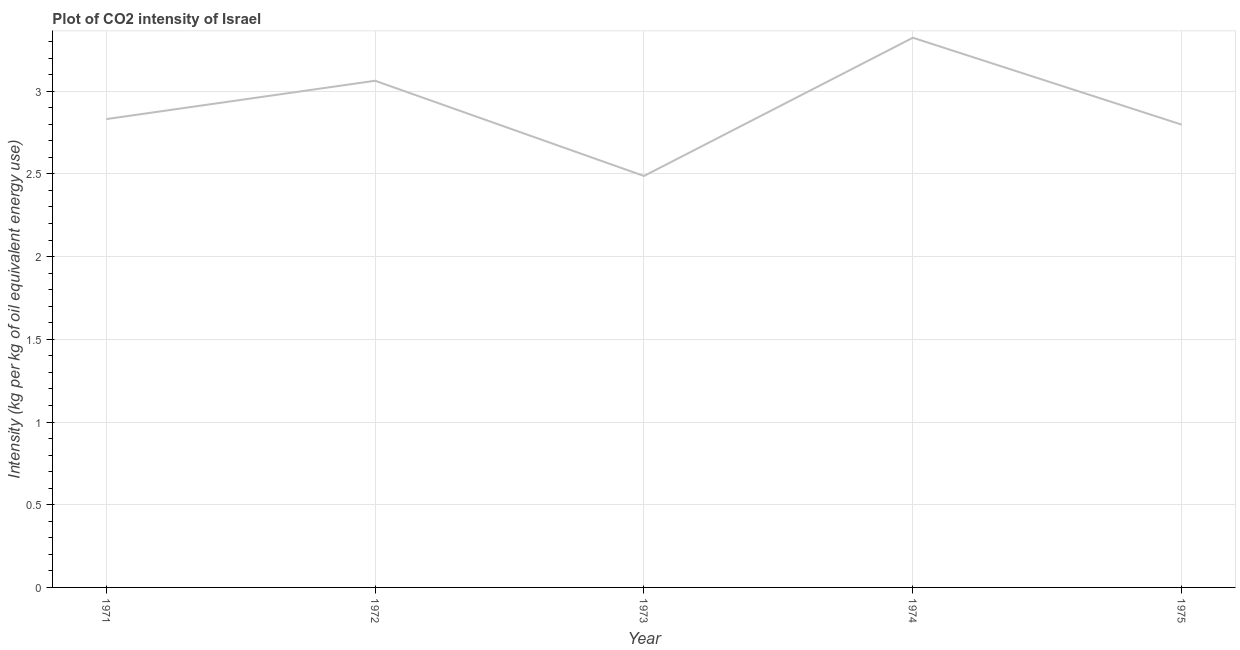What is the co2 intensity in 1974?
Keep it short and to the point. 3.32. Across all years, what is the maximum co2 intensity?
Provide a short and direct response. 3.32. Across all years, what is the minimum co2 intensity?
Offer a very short reply. 2.49. In which year was the co2 intensity maximum?
Your answer should be compact. 1974. In which year was the co2 intensity minimum?
Provide a succinct answer. 1973. What is the sum of the co2 intensity?
Your answer should be very brief. 14.5. What is the difference between the co2 intensity in 1971 and 1974?
Your answer should be very brief. -0.49. What is the average co2 intensity per year?
Provide a succinct answer. 2.9. What is the median co2 intensity?
Your response must be concise. 2.83. In how many years, is the co2 intensity greater than 2.9 kg?
Offer a very short reply. 2. Do a majority of the years between 1974 and 1975 (inclusive) have co2 intensity greater than 2.8 kg?
Ensure brevity in your answer.  No. What is the ratio of the co2 intensity in 1973 to that in 1975?
Provide a succinct answer. 0.89. Is the co2 intensity in 1972 less than that in 1974?
Keep it short and to the point. Yes. What is the difference between the highest and the second highest co2 intensity?
Provide a short and direct response. 0.26. Is the sum of the co2 intensity in 1974 and 1975 greater than the maximum co2 intensity across all years?
Provide a succinct answer. Yes. What is the difference between the highest and the lowest co2 intensity?
Provide a short and direct response. 0.84. Does the co2 intensity monotonically increase over the years?
Provide a succinct answer. No. How many lines are there?
Your answer should be very brief. 1. What is the title of the graph?
Your response must be concise. Plot of CO2 intensity of Israel. What is the label or title of the Y-axis?
Your answer should be very brief. Intensity (kg per kg of oil equivalent energy use). What is the Intensity (kg per kg of oil equivalent energy use) in 1971?
Give a very brief answer. 2.83. What is the Intensity (kg per kg of oil equivalent energy use) in 1972?
Offer a terse response. 3.06. What is the Intensity (kg per kg of oil equivalent energy use) of 1973?
Offer a very short reply. 2.49. What is the Intensity (kg per kg of oil equivalent energy use) of 1974?
Your response must be concise. 3.32. What is the Intensity (kg per kg of oil equivalent energy use) in 1975?
Keep it short and to the point. 2.8. What is the difference between the Intensity (kg per kg of oil equivalent energy use) in 1971 and 1972?
Offer a very short reply. -0.23. What is the difference between the Intensity (kg per kg of oil equivalent energy use) in 1971 and 1973?
Give a very brief answer. 0.34. What is the difference between the Intensity (kg per kg of oil equivalent energy use) in 1971 and 1974?
Keep it short and to the point. -0.49. What is the difference between the Intensity (kg per kg of oil equivalent energy use) in 1971 and 1975?
Make the answer very short. 0.03. What is the difference between the Intensity (kg per kg of oil equivalent energy use) in 1972 and 1973?
Make the answer very short. 0.58. What is the difference between the Intensity (kg per kg of oil equivalent energy use) in 1972 and 1974?
Offer a very short reply. -0.26. What is the difference between the Intensity (kg per kg of oil equivalent energy use) in 1972 and 1975?
Keep it short and to the point. 0.27. What is the difference between the Intensity (kg per kg of oil equivalent energy use) in 1973 and 1974?
Offer a terse response. -0.84. What is the difference between the Intensity (kg per kg of oil equivalent energy use) in 1973 and 1975?
Offer a terse response. -0.31. What is the difference between the Intensity (kg per kg of oil equivalent energy use) in 1974 and 1975?
Ensure brevity in your answer.  0.53. What is the ratio of the Intensity (kg per kg of oil equivalent energy use) in 1971 to that in 1972?
Provide a short and direct response. 0.92. What is the ratio of the Intensity (kg per kg of oil equivalent energy use) in 1971 to that in 1973?
Make the answer very short. 1.14. What is the ratio of the Intensity (kg per kg of oil equivalent energy use) in 1971 to that in 1974?
Provide a short and direct response. 0.85. What is the ratio of the Intensity (kg per kg of oil equivalent energy use) in 1971 to that in 1975?
Your answer should be compact. 1.01. What is the ratio of the Intensity (kg per kg of oil equivalent energy use) in 1972 to that in 1973?
Provide a short and direct response. 1.23. What is the ratio of the Intensity (kg per kg of oil equivalent energy use) in 1972 to that in 1974?
Offer a terse response. 0.92. What is the ratio of the Intensity (kg per kg of oil equivalent energy use) in 1972 to that in 1975?
Give a very brief answer. 1.09. What is the ratio of the Intensity (kg per kg of oil equivalent energy use) in 1973 to that in 1974?
Keep it short and to the point. 0.75. What is the ratio of the Intensity (kg per kg of oil equivalent energy use) in 1973 to that in 1975?
Provide a short and direct response. 0.89. What is the ratio of the Intensity (kg per kg of oil equivalent energy use) in 1974 to that in 1975?
Provide a short and direct response. 1.19. 